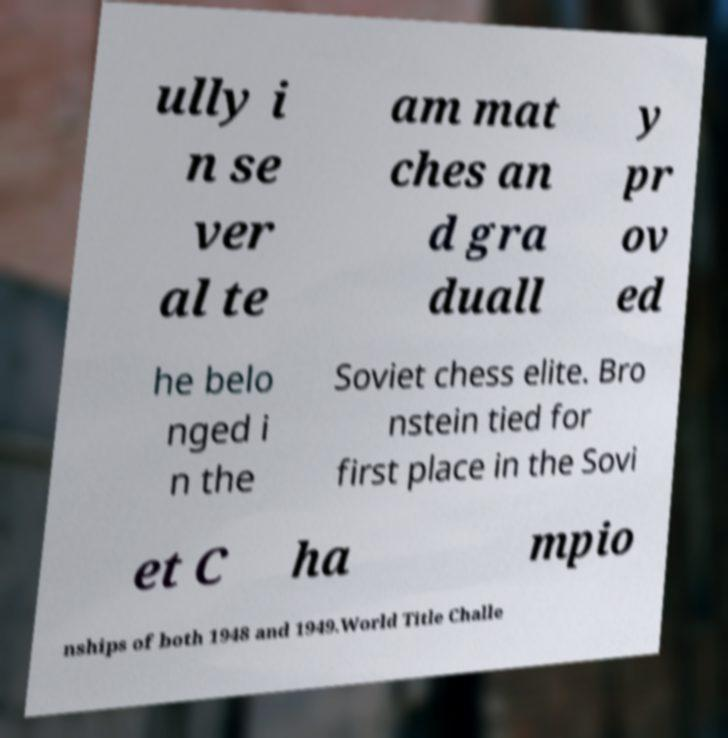Please read and relay the text visible in this image. What does it say? ully i n se ver al te am mat ches an d gra duall y pr ov ed he belo nged i n the Soviet chess elite. Bro nstein tied for first place in the Sovi et C ha mpio nships of both 1948 and 1949.World Title Challe 